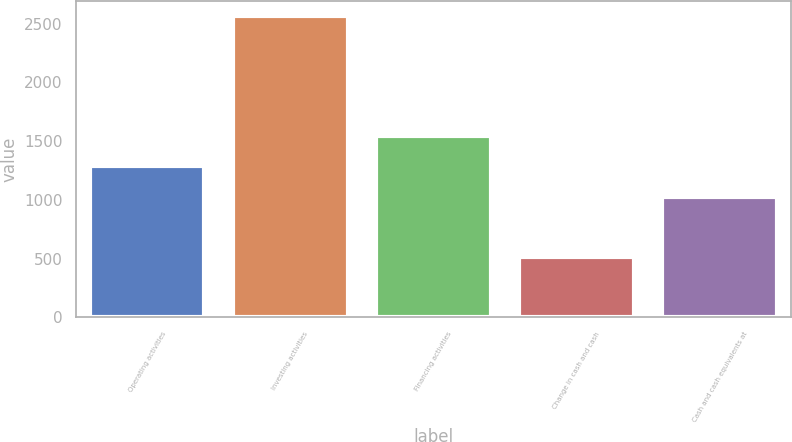Convert chart to OTSL. <chart><loc_0><loc_0><loc_500><loc_500><bar_chart><fcel>Operating activities<fcel>Investing activities<fcel>Financing activities<fcel>Change in cash and cash<fcel>Cash and cash equivalents at<nl><fcel>1285.6<fcel>2566.2<fcel>1541.89<fcel>515.88<fcel>1028.46<nl></chart> 